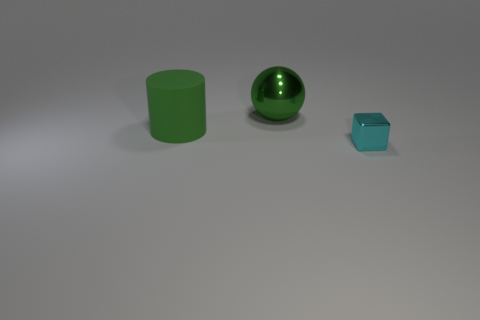What materials do the objects in the image seem to be made of? The large ball appears to have a metallic sheen, indicating it could be made of metal. The cylindrical object has a matte finish and could be made of plastic or painted wood, while the smaller cube looks like it could also be a type of glossy-painted plastic. 